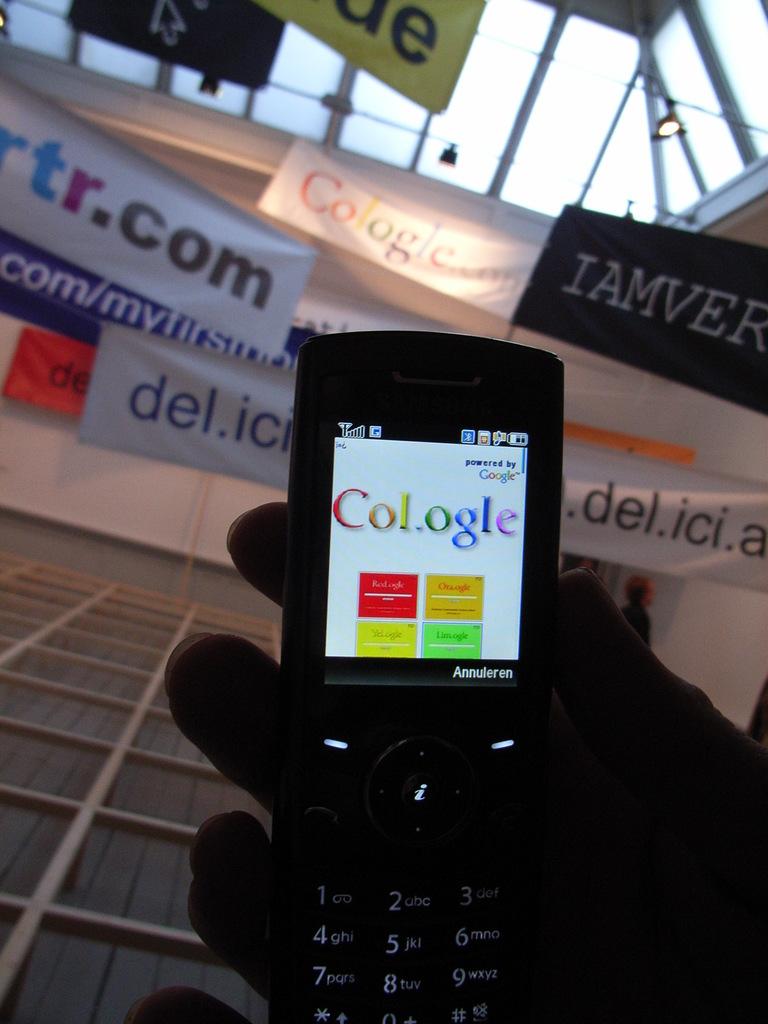What word/s does the screen display?
Provide a succinct answer. Cologle. What brand of phone is that?
Ensure brevity in your answer.  Annuleren. 